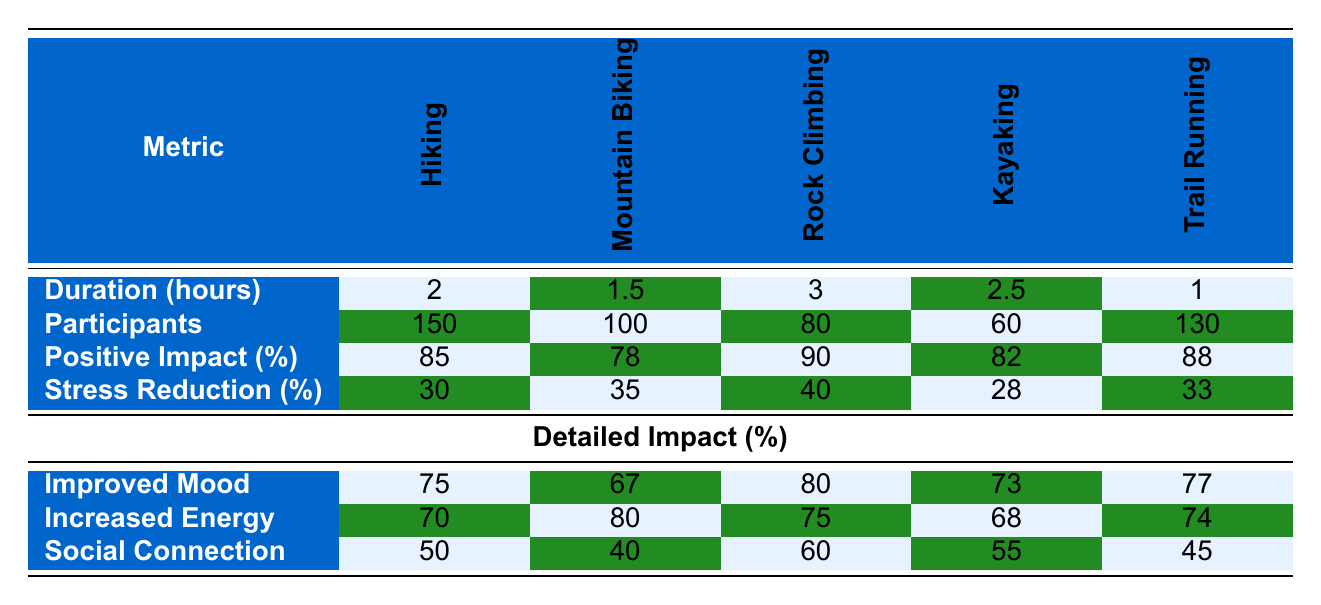What is the duration of the Rock Climbing activity? The table shows that the duration hours for Rock Climbing is listed in the respective column under "Duration (hours)." It clearly states that Rock Climbing lasts for 3 hours.
Answer: 3 Which outdoor activity had the highest positive impact percentage? By comparing the "Positive Impact (%)" row across all activities, Rock Climbing has the highest value at 90%.
Answer: Rock Climbing What is the average stress reduction for Hiking and Kayaking? From the "Stress Reduction (%)" row, Hiking has a stress reduction of 30% and Kayaking has 28%. Adding these figures gives 30 + 28 = 58. Then dividing by the number of activities (2) gives an average of 58/2 = 29%.
Answer: 29% How many participants engaged in Trail Running? Referring to the "Participants" row, it shows that 130 participants were involved in Trail Running.
Answer: 130 Did Mountain Biking have a higher percentage of participants reporting improved mood than Kayaking? Looking at the "Improved Mood" percentages, Mountain Biking has 67% and Kayaking has 73%. Since 67% is less than 73%, the statement is false.
Answer: No What is the total number of participants across all activities? To find the total, we can sum the participants for all activities: 150 (Hiking) + 100 (Mountain Biking) + 80 (Rock Climbing) + 60 (Kayaking) + 130 (Trail Running) = 620.
Answer: 620 Which activity had the least number of participants? By reviewing the "Participants" row, Kayaking with only 60 participants is the lowest among all listed activities.
Answer: Kayaking What is the percentage difference in improved mood between Hiking and Rock Climbing? The improved mood percentages are 75% for Hiking and 80% for Rock Climbing. The difference is calculated as 80 - 75 = 5%.
Answer: 5% How does the average duration of Mountain Biking and Trail Running compare to Rock Climbing? The average duration for Mountain Biking (1.5 hours) and Trail Running (1 hour) is (1.5 + 1) / 2 = 1.25 hours. Rock Climbing lasts 3 hours, which is greater than 1.25 hours.
Answer: 1.25 hours is less than 3 hours 